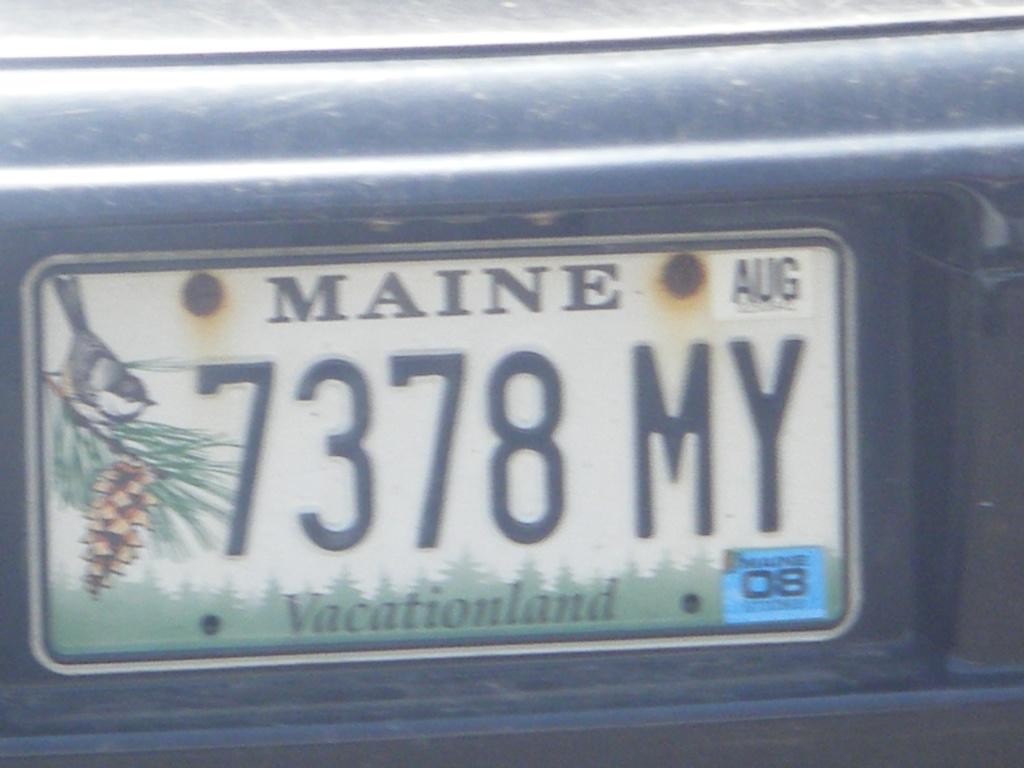What state is the license plate from?
Offer a terse response. Maine. What state is the license plate from?
Ensure brevity in your answer.  Maine. 